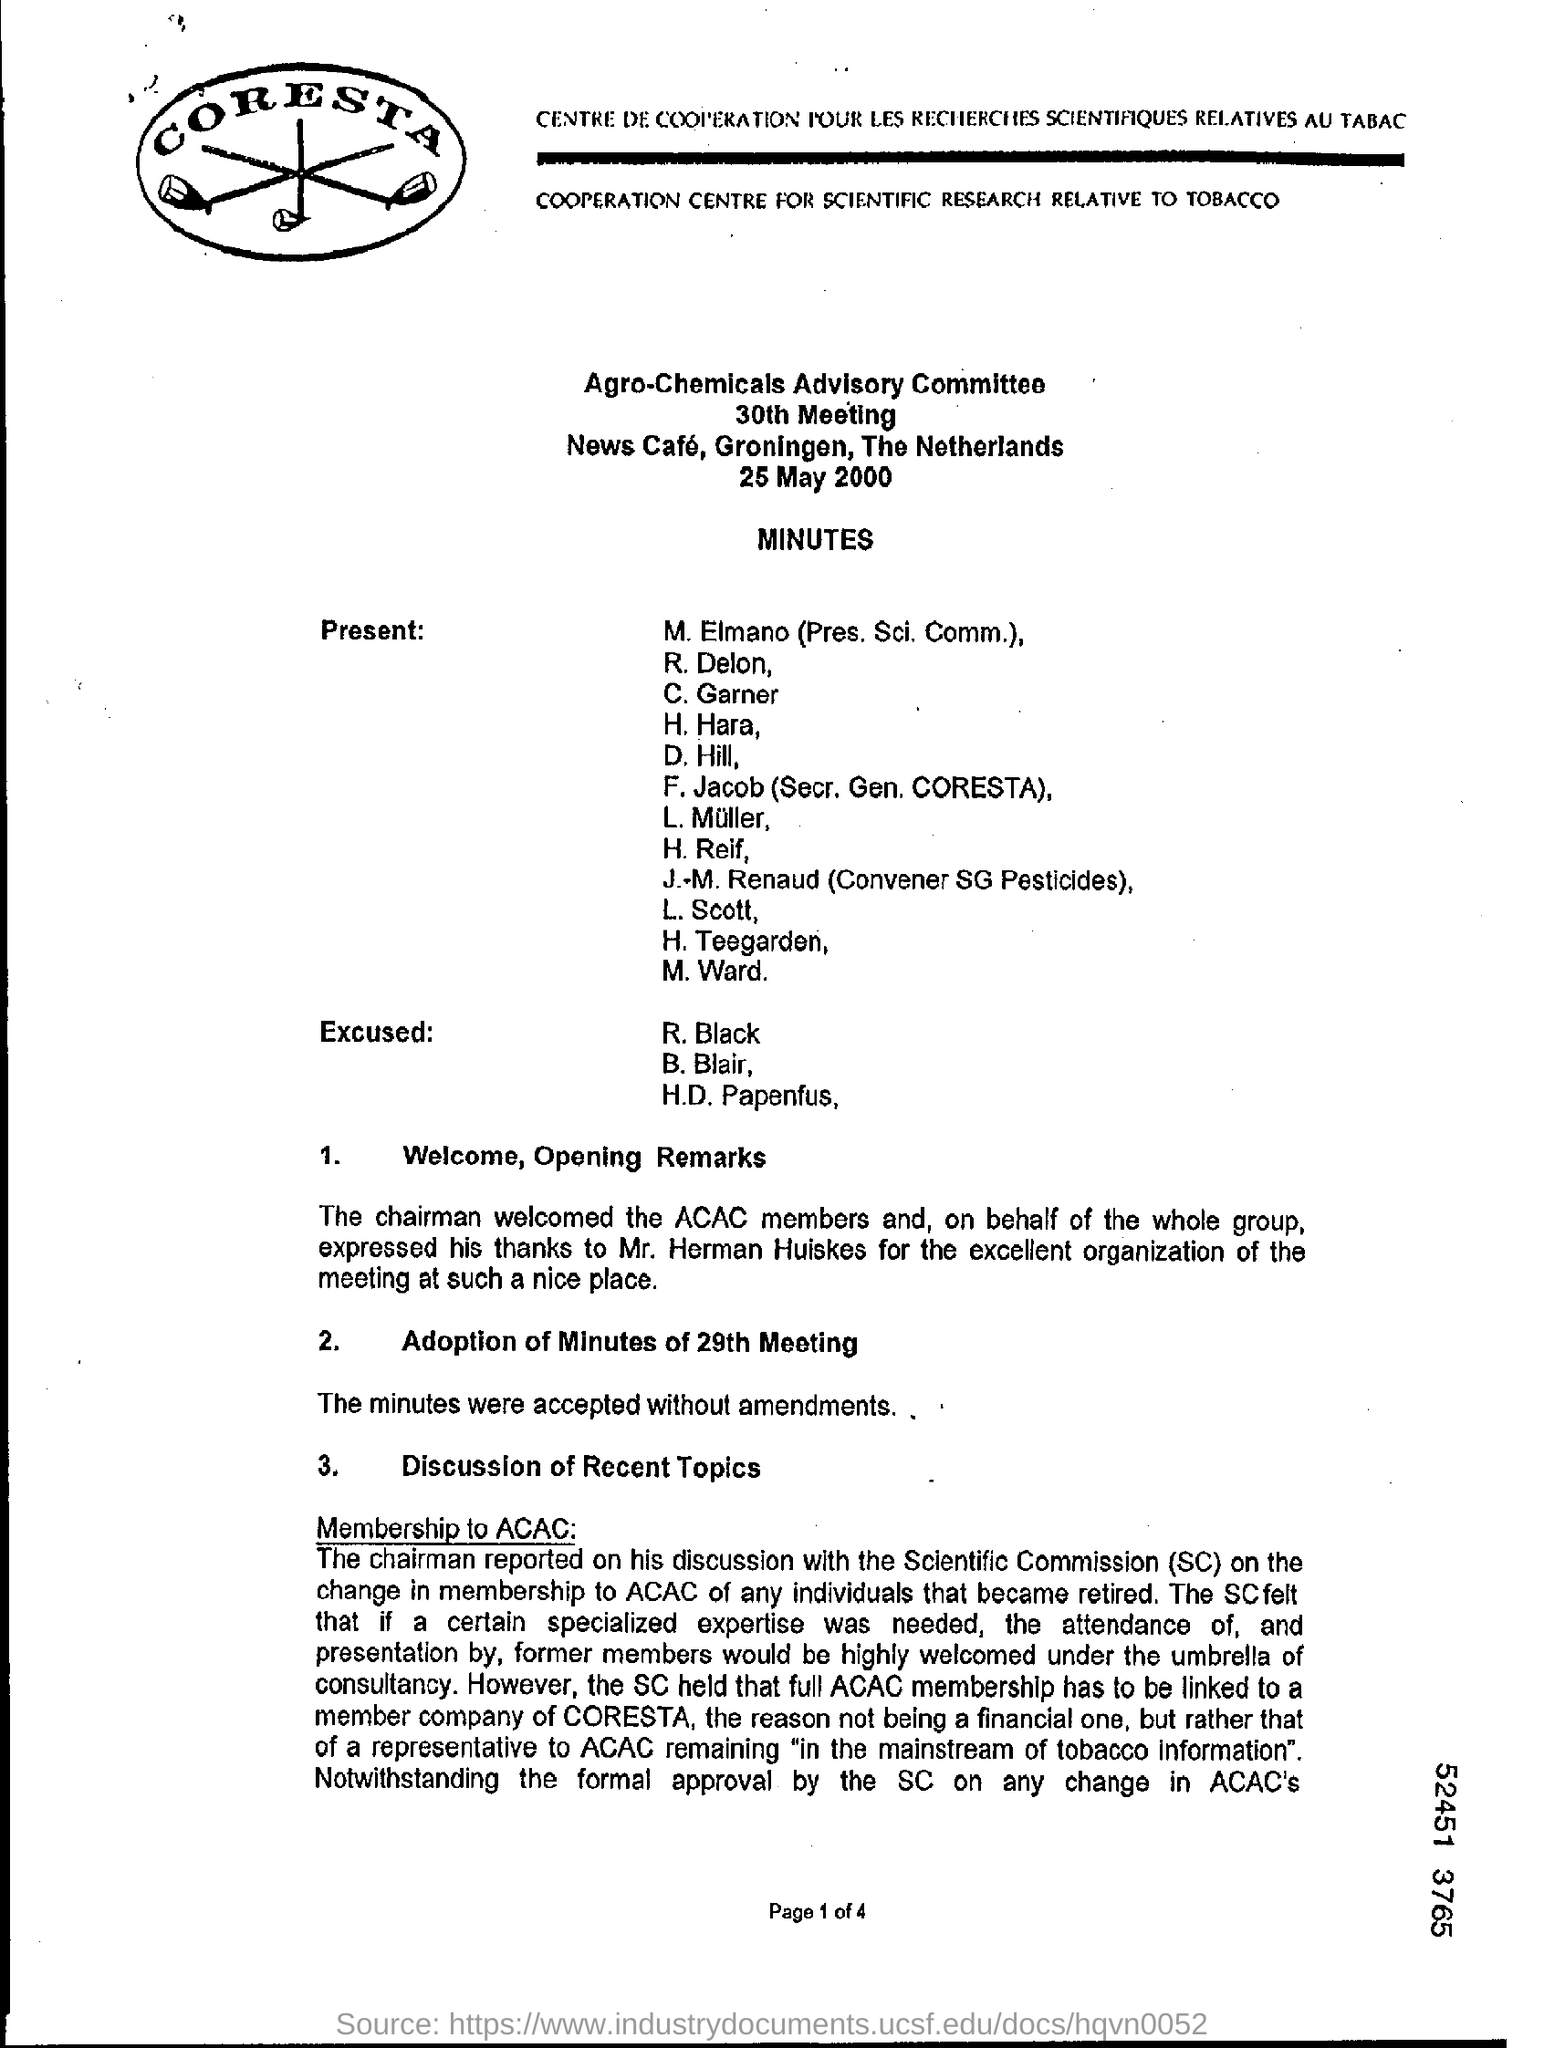Highlight a few significant elements in this photo. J. M. Renaud is the convener of SG pesticides. 